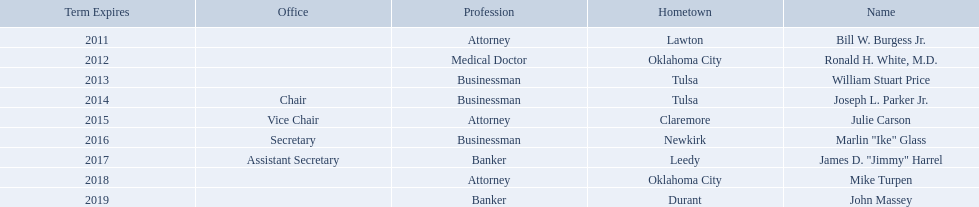Who are the businessmen? Bill W. Burgess Jr., Ronald H. White, M.D., William Stuart Price, Joseph L. Parker Jr., Julie Carson, Marlin "Ike" Glass, James D. "Jimmy" Harrel, Mike Turpen, John Massey. Which were born in tulsa? William Stuart Price, Joseph L. Parker Jr. Of these, which one was other than william stuart price? Joseph L. Parker Jr. What businessmen were born in tulsa? William Stuart Price, Joseph L. Parker Jr. Which man, other than price, was born in tulsa? Joseph L. Parker Jr. 